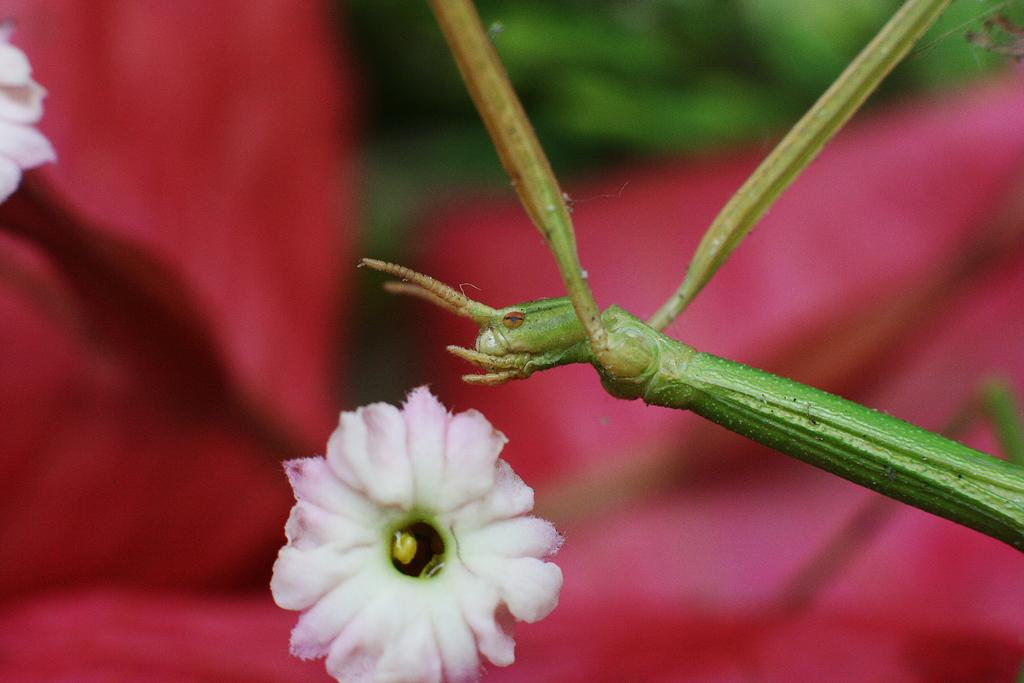What is the main subject of the image? There is a flower in the image. Are there any other living organisms present in the image? Yes, there is an insect in the image. How would you describe the background of the image? The background of the image is blurred. Can you see the kitty playing with the curve in the image? There is no kitty or curve present in the image. 